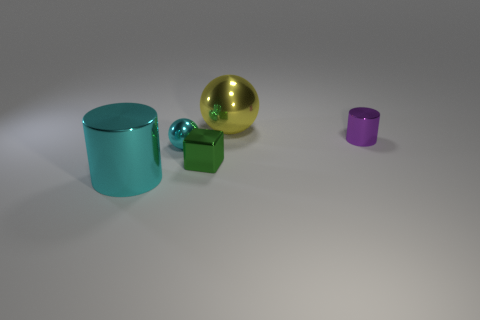Add 5 tiny purple metallic objects. How many objects exist? 10 Subtract all cylinders. How many objects are left? 3 Subtract 0 blue spheres. How many objects are left? 5 Subtract all big cyan things. Subtract all spheres. How many objects are left? 2 Add 5 yellow objects. How many yellow objects are left? 6 Add 3 tiny green things. How many tiny green things exist? 4 